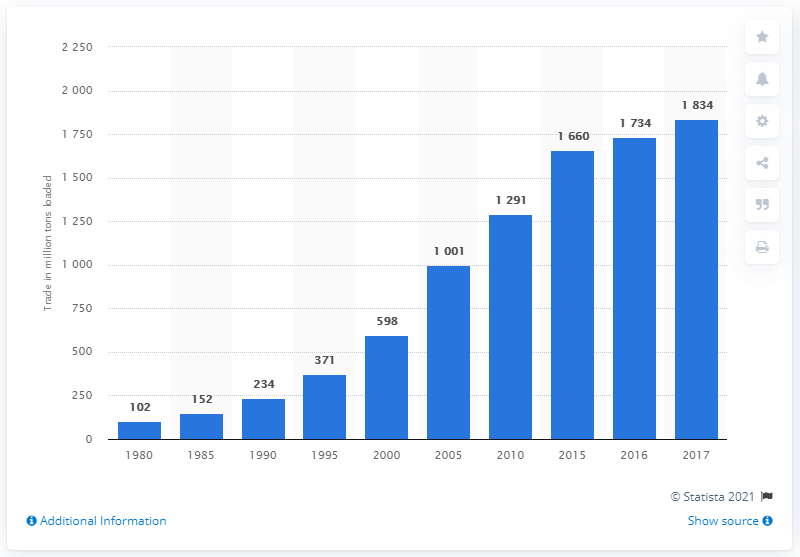Mention a couple of crucial points in this snapshot. In 2015, ships carried the third largest amount of trade. The combined number carried by ships for the lowest two years was 254. In 2017, the total amount of seaborne containerized cargo was 1,834. 